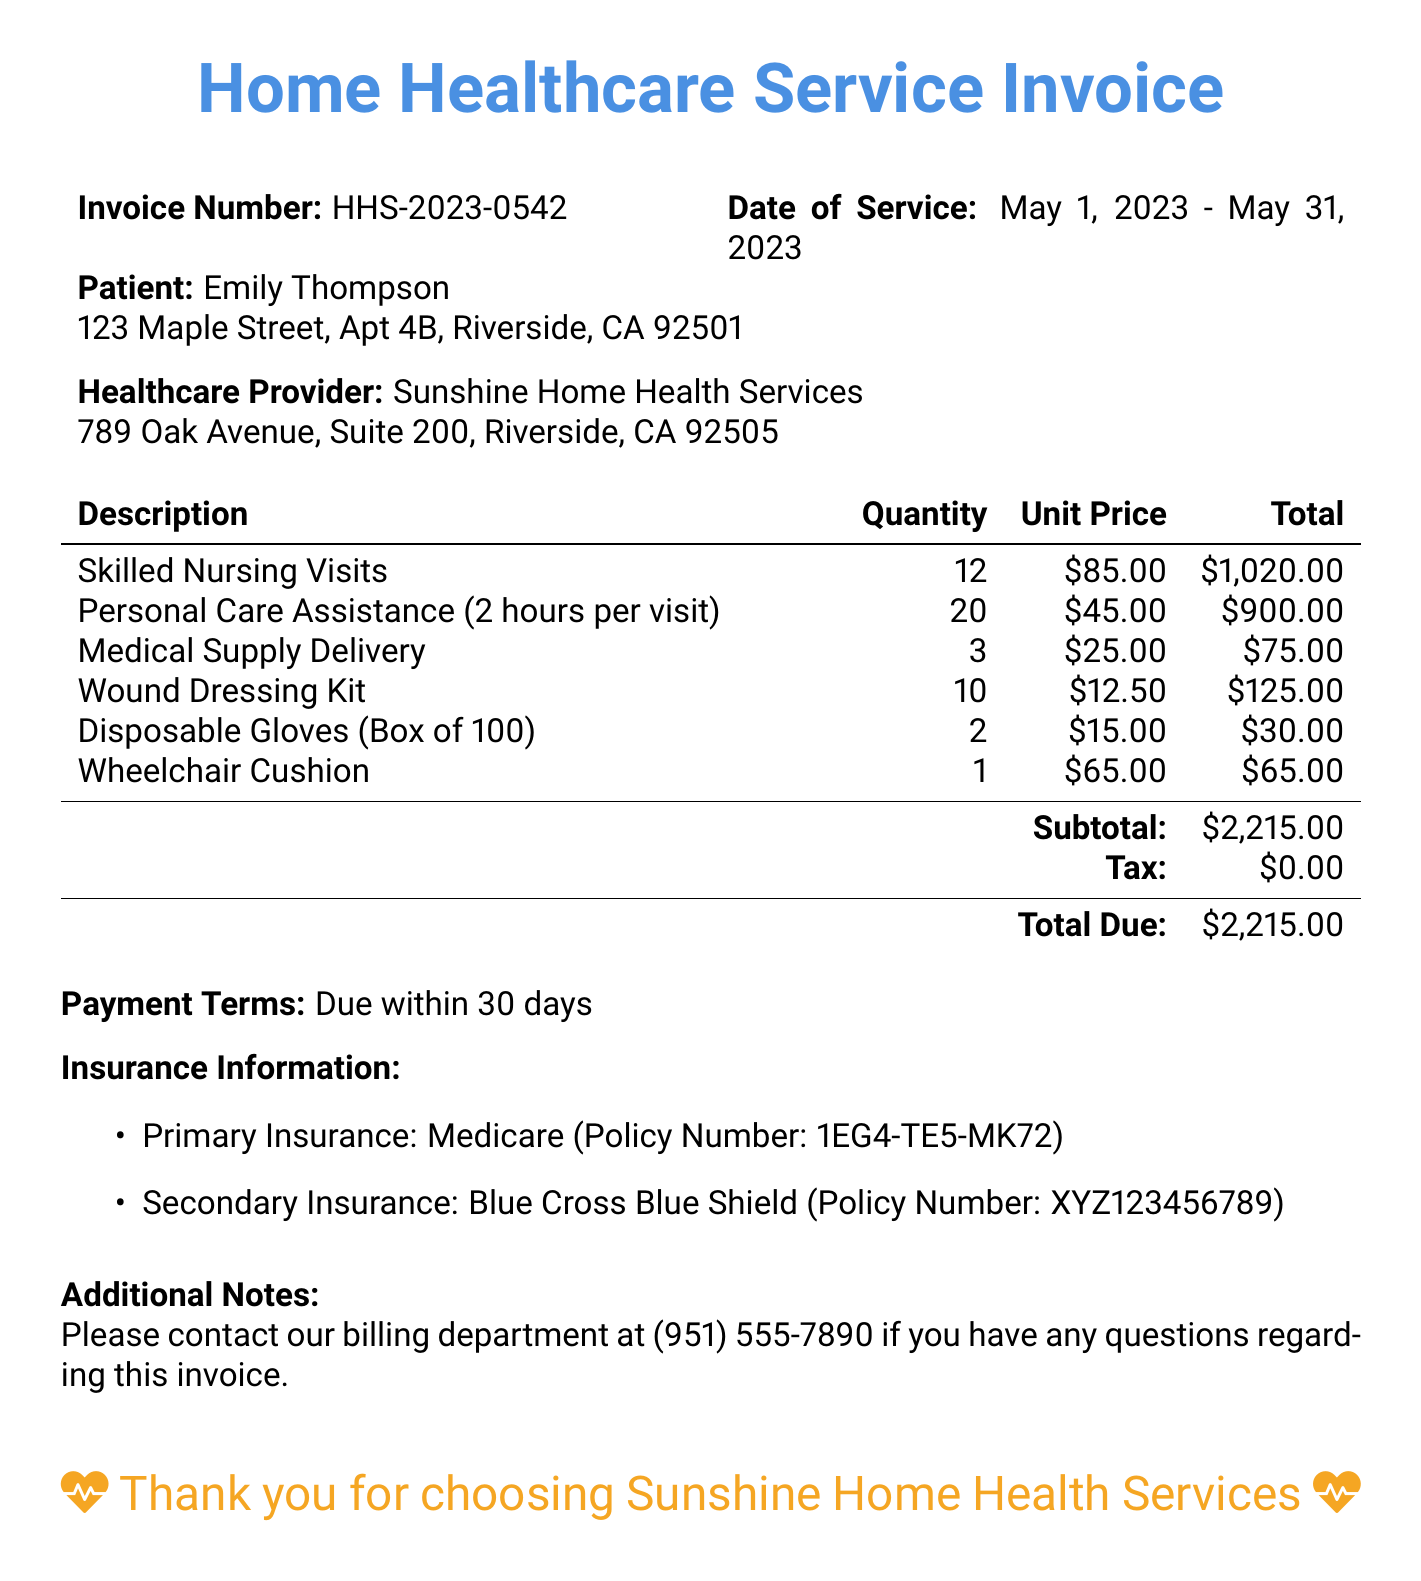What is the invoice number? The invoice number is explicitly listed in the document as HHS-2023-0542.
Answer: HHS-2023-0542 What is the date range of services? The date range of services is indicated in the document from May 1, 2023 to May 31, 2023.
Answer: May 1, 2023 - May 31, 2023 Who is the patient? The patient’s name is provided in the document as Emily Thompson.
Answer: Emily Thompson What is the total due amount? The total due amount is stated at the bottom of the invoice as $2,215.00.
Answer: $2,215.00 How many skilled nursing visits were provided? The document specifies that there were 12 skilled nursing visits.
Answer: 12 Which insurance is listed as the primary? The document identifies Medicare as the primary insurance.
Answer: Medicare What is the unit price for personal care assistance? The unit price for personal care assistance is specified as $45.00 per visit.
Answer: $45.00 How many medical supply deliveries were made? The invoice indicates that there were 3 medical supply deliveries.
Answer: 3 What is the payment term? The document states that the payment is due within 30 days.
Answer: Due within 30 days 